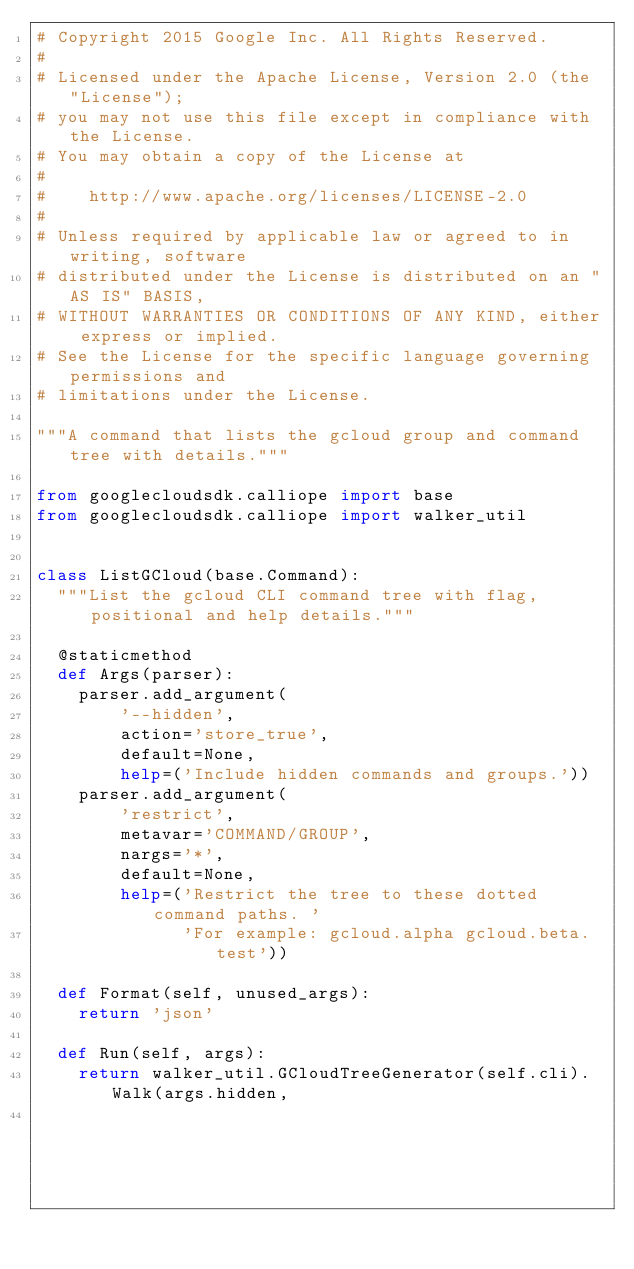<code> <loc_0><loc_0><loc_500><loc_500><_Python_># Copyright 2015 Google Inc. All Rights Reserved.
#
# Licensed under the Apache License, Version 2.0 (the "License");
# you may not use this file except in compliance with the License.
# You may obtain a copy of the License at
#
#    http://www.apache.org/licenses/LICENSE-2.0
#
# Unless required by applicable law or agreed to in writing, software
# distributed under the License is distributed on an "AS IS" BASIS,
# WITHOUT WARRANTIES OR CONDITIONS OF ANY KIND, either express or implied.
# See the License for the specific language governing permissions and
# limitations under the License.

"""A command that lists the gcloud group and command tree with details."""

from googlecloudsdk.calliope import base
from googlecloudsdk.calliope import walker_util


class ListGCloud(base.Command):
  """List the gcloud CLI command tree with flag, positional and help details."""

  @staticmethod
  def Args(parser):
    parser.add_argument(
        '--hidden',
        action='store_true',
        default=None,
        help=('Include hidden commands and groups.'))
    parser.add_argument(
        'restrict',
        metavar='COMMAND/GROUP',
        nargs='*',
        default=None,
        help=('Restrict the tree to these dotted command paths. '
              'For example: gcloud.alpha gcloud.beta.test'))

  def Format(self, unused_args):
    return 'json'

  def Run(self, args):
    return walker_util.GCloudTreeGenerator(self.cli).Walk(args.hidden,
                                                          args.restrict)
</code> 